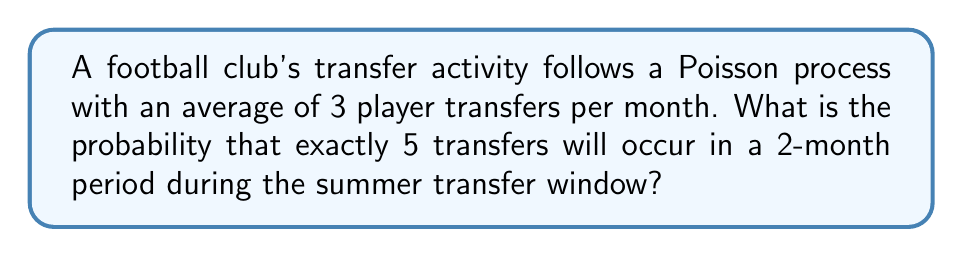Can you solve this math problem? Let's approach this step-by-step:

1) First, we need to identify the key parameters:
   - Rate (λ) = 3 transfers per month
   - Time period (t) = 2 months
   - Number of events (k) = 5 transfers

2) For a Poisson process, the rate over the entire time period is:
   λt = 3 * 2 = 6 transfers expected in 2 months

3) The probability of exactly k events in a Poisson process is given by the formula:

   $$P(X = k) = \frac{e^{-λt}(λt)^k}{k!}$$

4) Substituting our values:

   $$P(X = 5) = \frac{e^{-6}(6)^5}{5!}$$

5) Let's calculate this step-by-step:
   
   $$\frac{e^{-6} * 6^5}{5!} = \frac{e^{-6} * 7776}{120}$$

6) Using a calculator:

   $$\frac{0.00248 * 7776}{120} \approx 0.1606$$

7) Therefore, the probability is approximately 0.1606 or 16.06%.

This probability aligns with what a dedicated football fandom might expect: while 5 transfers in 2 months is above the average (which would be 6 in 2 months), it's not uncommon during busy transfer windows.
Answer: 0.1606 